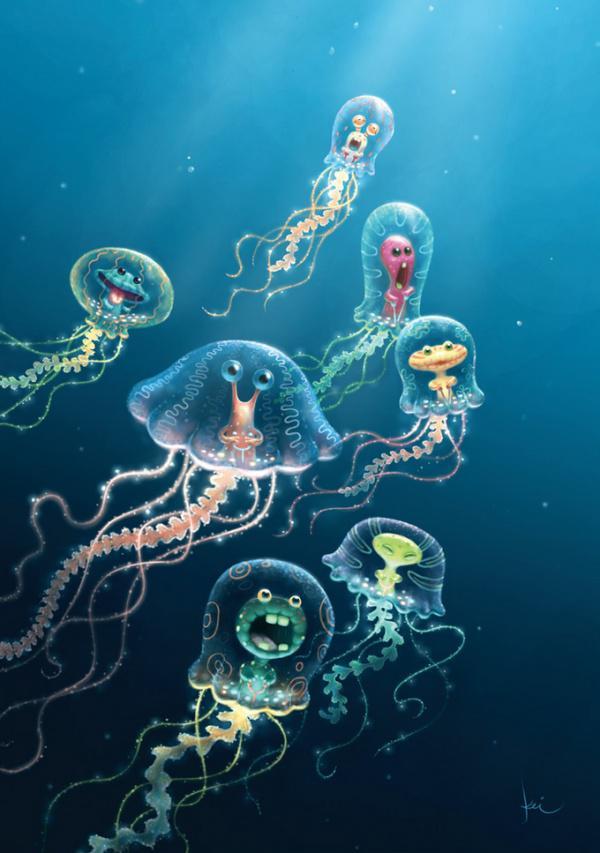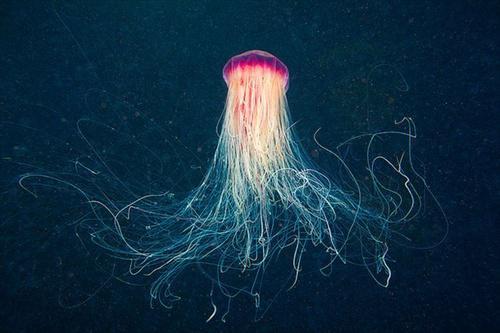The first image is the image on the left, the second image is the image on the right. Assess this claim about the two images: "The foreground of an image shows one pale, translucent, saucer-shaped jellyfish without long tendrils.". Correct or not? Answer yes or no. No. The first image is the image on the left, the second image is the image on the right. Given the left and right images, does the statement "One image shows one or more jellyfish with short tentacles, while the other shows a single jellyfish with long tentacles." hold true? Answer yes or no. No. 